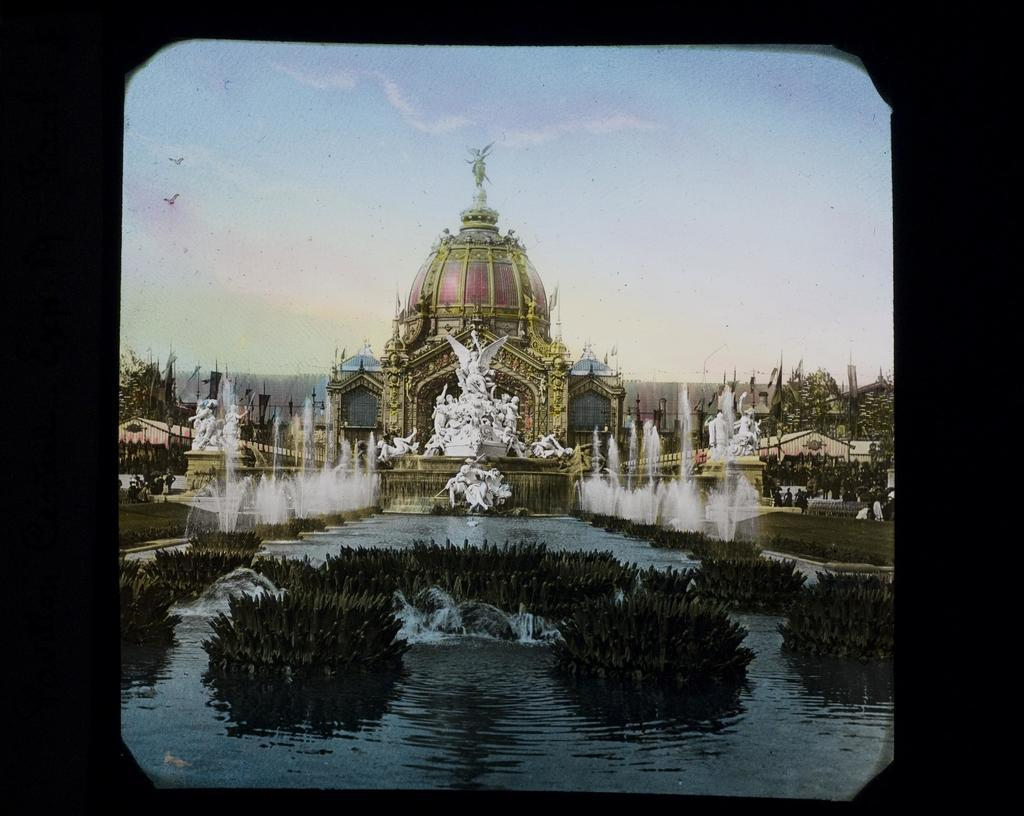What type of structure is present in the image? There is a castle in the image. What other objects or features can be seen in the image? There are sculptures, a water fountain, plants, and trees in the image. What is visible in the background of the image? The sky is visible in the background of the image. What type of knife is being used to carve the stone sculpture in the image? There is no knife or stone sculpture present in the image. What color is the pin on the tree in the image? There is no pin on the tree in the image. 